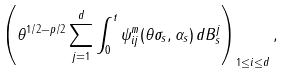Convert formula to latex. <formula><loc_0><loc_0><loc_500><loc_500>\left ( \theta ^ { 1 / 2 - p / 2 } \sum _ { j = 1 } ^ { d } \int _ { 0 } ^ { t } \psi _ { i j } ^ { m } ( \theta \sigma _ { s } , \alpha _ { s } ) \, d B ^ { j } _ { s } \right ) _ { 1 \leq i \leq d } ,</formula> 